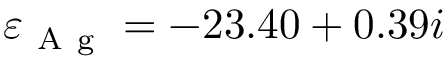<formula> <loc_0><loc_0><loc_500><loc_500>\varepsilon _ { A g } = - 2 3 . 4 0 + 0 . 3 9 i</formula> 